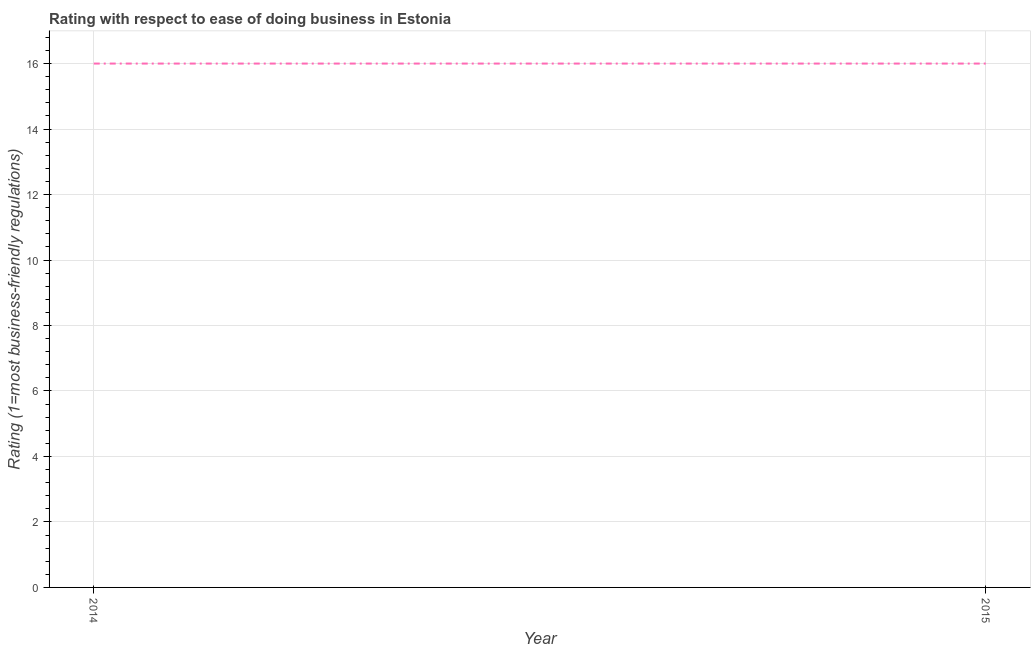What is the ease of doing business index in 2014?
Your answer should be very brief. 16. Across all years, what is the maximum ease of doing business index?
Your response must be concise. 16. Across all years, what is the minimum ease of doing business index?
Your answer should be very brief. 16. In which year was the ease of doing business index maximum?
Provide a succinct answer. 2014. What is the sum of the ease of doing business index?
Offer a very short reply. 32. What is the difference between the ease of doing business index in 2014 and 2015?
Offer a very short reply. 0. What is the average ease of doing business index per year?
Your answer should be compact. 16. In how many years, is the ease of doing business index greater than 7.2 ?
Provide a succinct answer. 2. Do a majority of the years between 2015 and 2014 (inclusive) have ease of doing business index greater than 3.2 ?
Keep it short and to the point. No. Is the ease of doing business index in 2014 less than that in 2015?
Your answer should be compact. No. How many lines are there?
Make the answer very short. 1. How many years are there in the graph?
Offer a terse response. 2. Does the graph contain any zero values?
Make the answer very short. No. What is the title of the graph?
Provide a short and direct response. Rating with respect to ease of doing business in Estonia. What is the label or title of the Y-axis?
Your answer should be very brief. Rating (1=most business-friendly regulations). What is the Rating (1=most business-friendly regulations) of 2015?
Your answer should be compact. 16. What is the difference between the Rating (1=most business-friendly regulations) in 2014 and 2015?
Make the answer very short. 0. What is the ratio of the Rating (1=most business-friendly regulations) in 2014 to that in 2015?
Your response must be concise. 1. 